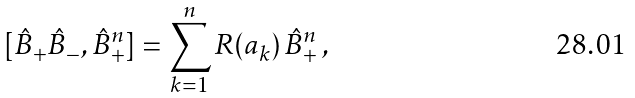<formula> <loc_0><loc_0><loc_500><loc_500>[ \hat { B } _ { + } \hat { B } _ { - } , \hat { B } _ { + } ^ { n } ] = \sum _ { k = 1 } ^ { n } R ( a _ { k } ) \, \hat { B } _ { + } ^ { n } \, ,</formula> 